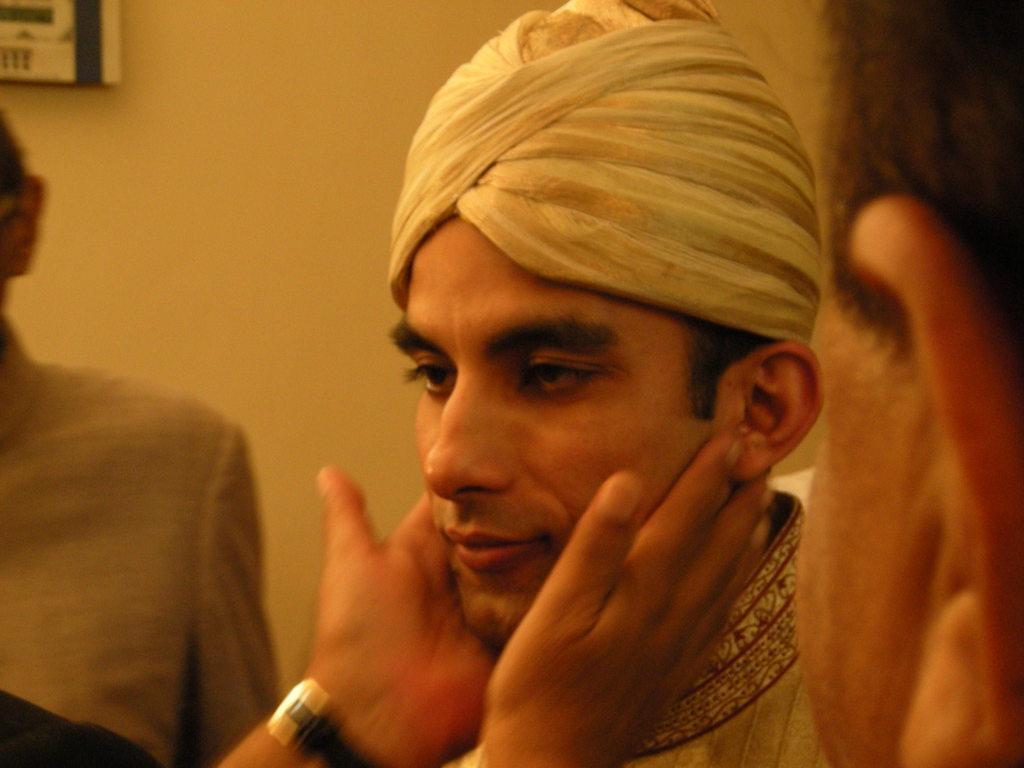How would you summarize this image in a sentence or two? This picture might be taken inside the room. In this image, on the right side, we can see a person head. In the middle of the image, we can see a man wearing a hat and his cheeks are holed by some other person who is wearing a black color watch. On the left side, we can also see another person. In the background, we can also see an electronic machine which is attached to a wall. 